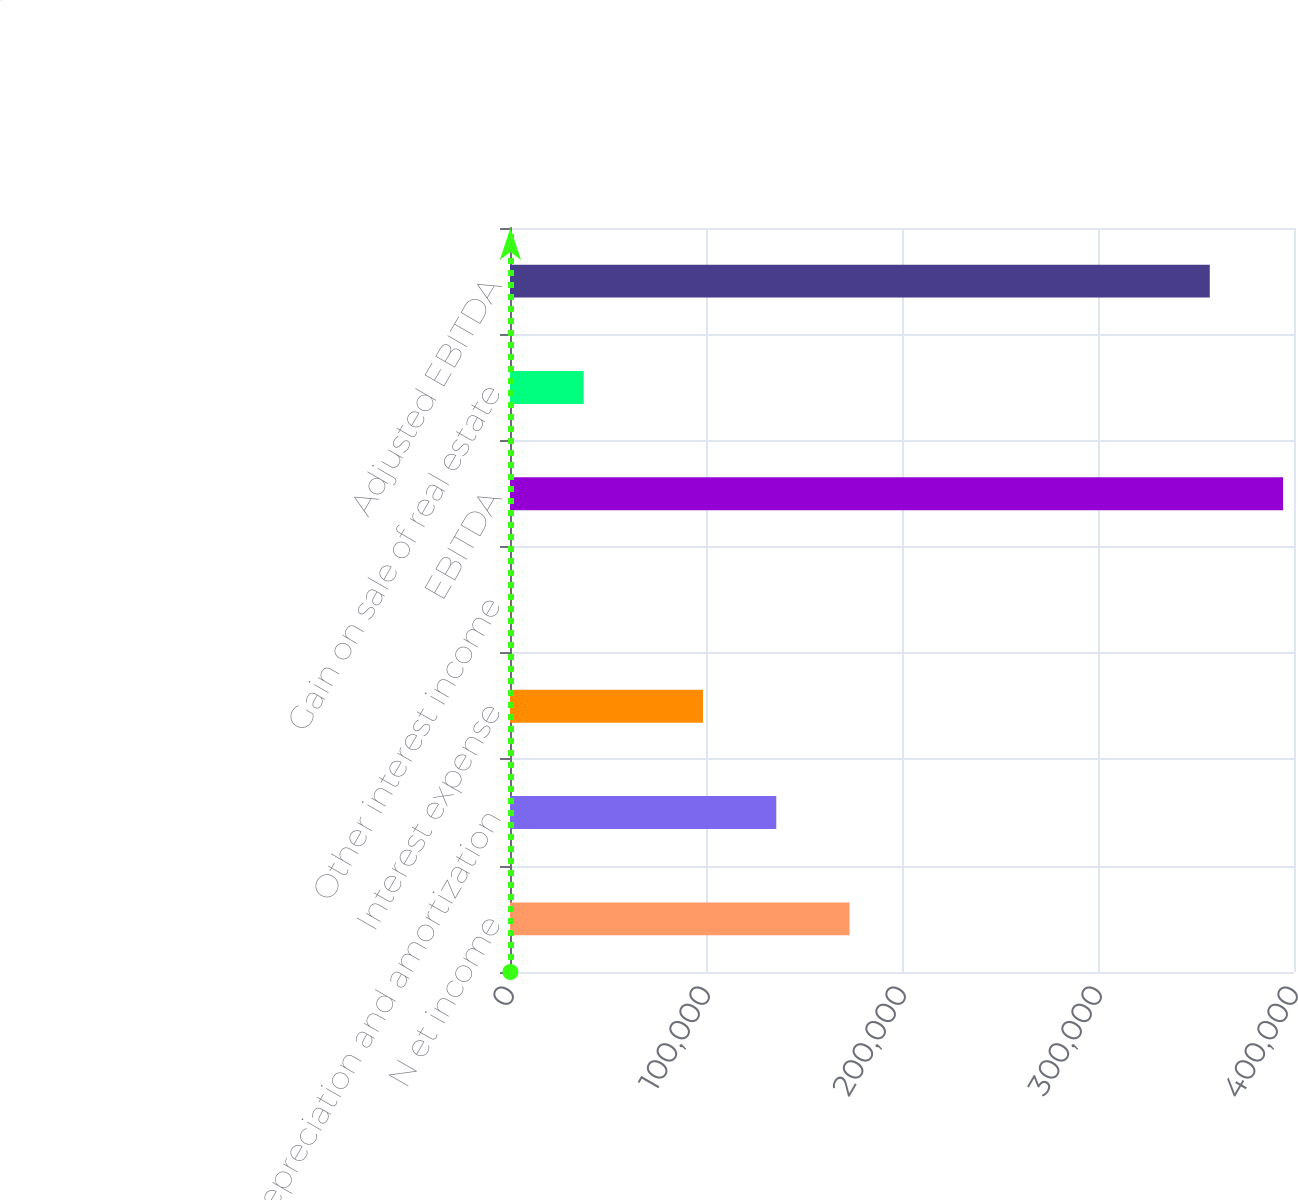Convert chart to OTSL. <chart><loc_0><loc_0><loc_500><loc_500><bar_chart><fcel>N et income<fcel>Depreciation and amortization<fcel>Interest expense<fcel>Other interest income<fcel>EBITDA<fcel>Gain on sale of real estate<fcel>Adjusted EBITDA<nl><fcel>173248<fcel>135856<fcel>98465<fcel>218<fcel>394421<fcel>37609.3<fcel>357030<nl></chart> 